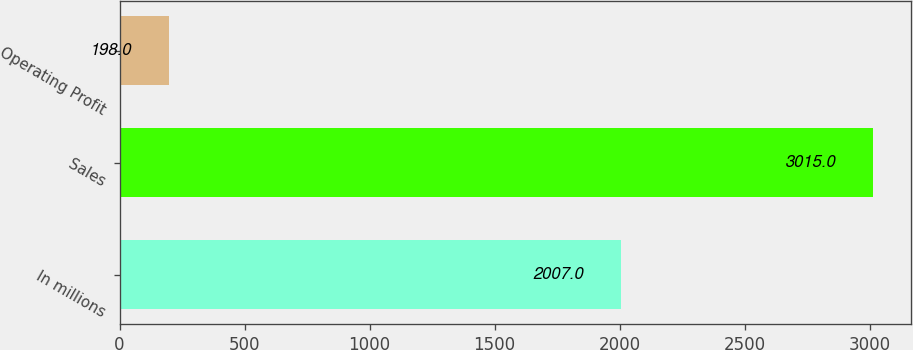Convert chart to OTSL. <chart><loc_0><loc_0><loc_500><loc_500><bar_chart><fcel>In millions<fcel>Sales<fcel>Operating Profit<nl><fcel>2007<fcel>3015<fcel>198<nl></chart> 